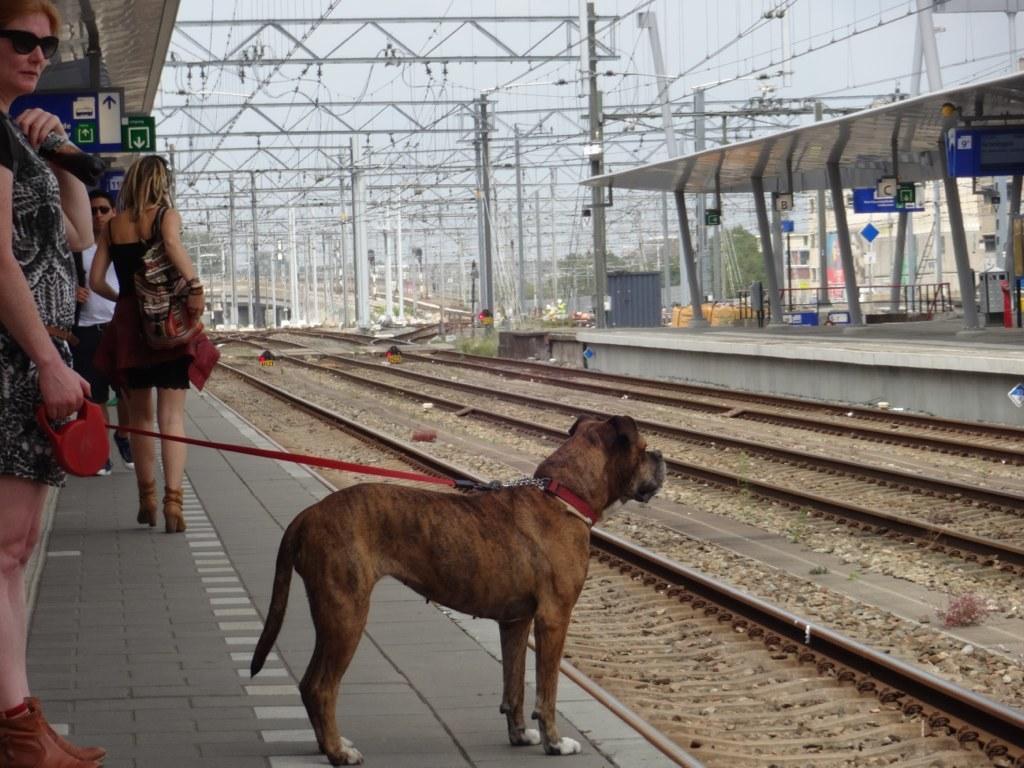How would you summarize this image in a sentence or two? This image is clicked in railway station. At the bottom, there are tracks along with stones. In the front, we can see a dog and few people standing on the platform. On the right, there is another platform. In the front, we can see many electric poles and wires. 